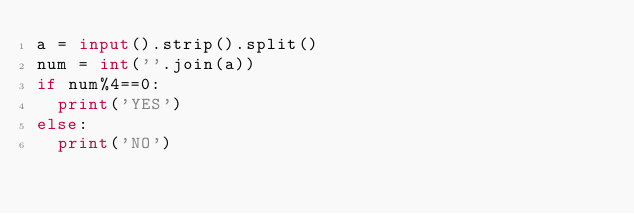<code> <loc_0><loc_0><loc_500><loc_500><_Python_>a = input().strip().split()
num = int(''.join(a))
if num%4==0:
  print('YES')
else:
  print('NO')</code> 